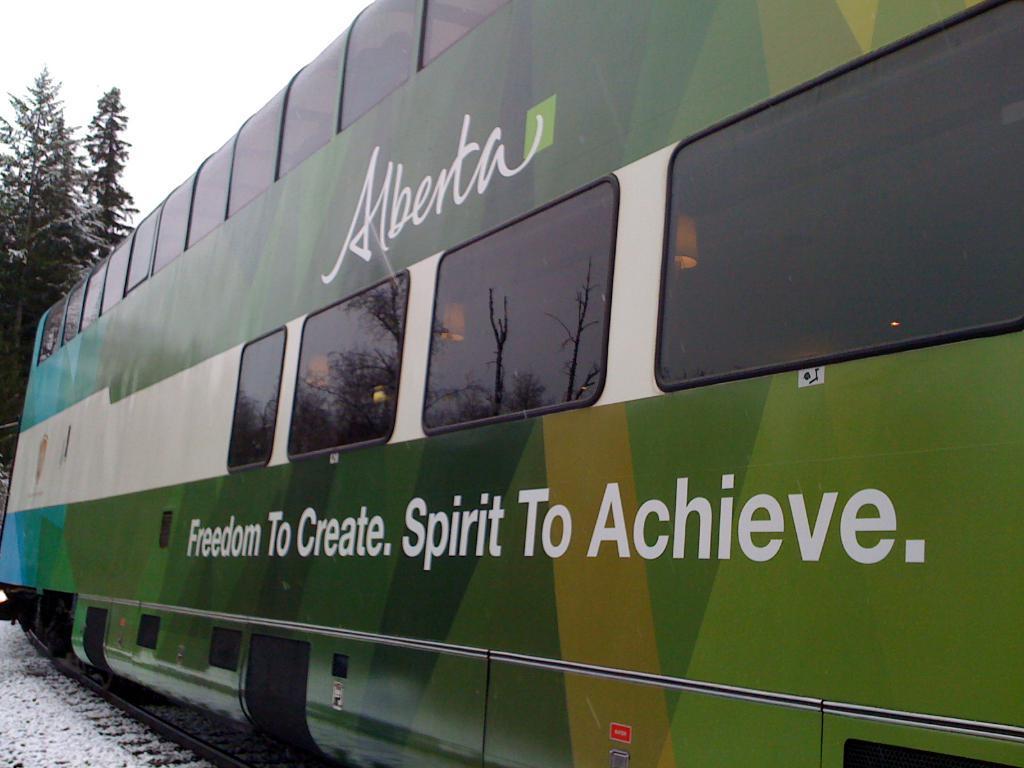Could you give a brief overview of what you see in this image? In the foreground of this image, there is a compartment of a train on the track. On the bottom, there is the snow. In the background, there is a tree and the sky. 